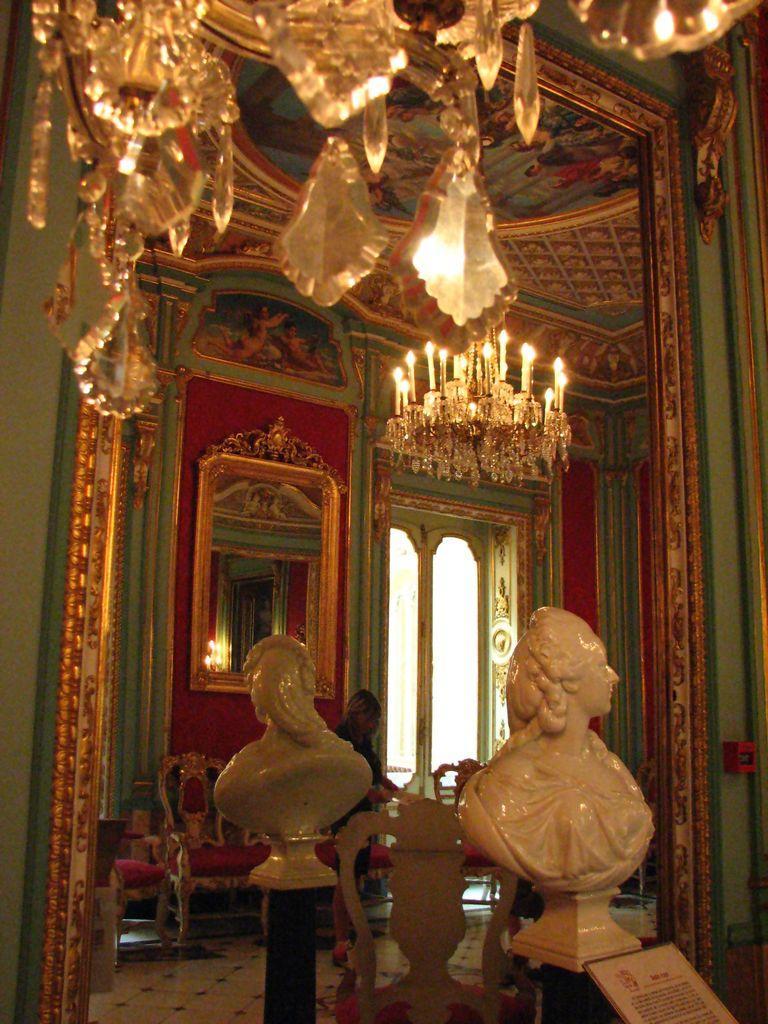Describe this image in one or two sentences. In this image I see the sculpture over here and I see the mirror over here and in the reflection I see the wall and the ceiling and I see the chandelier over here and I see the chairs and I see a person over here and I see the floor and I see a board over here and I see the windows over here. 